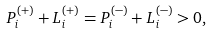Convert formula to latex. <formula><loc_0><loc_0><loc_500><loc_500>P ^ { ( + ) } _ { i } + L ^ { ( + ) } _ { i } = P ^ { ( - ) } _ { i } + L ^ { ( - ) } _ { i } > 0 ,</formula> 